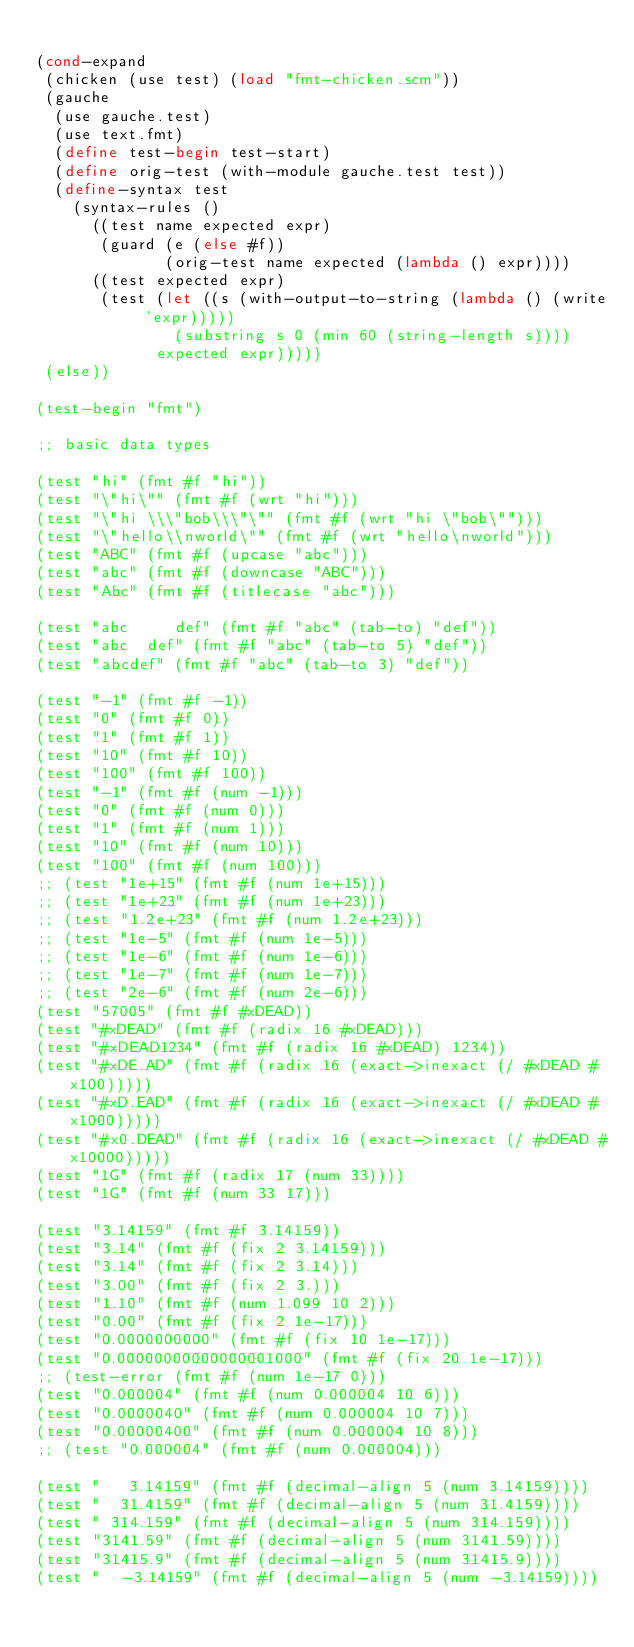<code> <loc_0><loc_0><loc_500><loc_500><_Scheme_>
(cond-expand
 (chicken (use test) (load "fmt-chicken.scm"))
 (gauche
  (use gauche.test)
  (use text.fmt)
  (define test-begin test-start)
  (define orig-test (with-module gauche.test test))
  (define-syntax test
    (syntax-rules ()
      ((test name expected expr)
       (guard (e (else #f))
              (orig-test name expected (lambda () expr))))
      ((test expected expr)
       (test (let ((s (with-output-to-string (lambda () (write 'expr)))))
               (substring s 0 (min 60 (string-length s))))
             expected expr)))))
 (else))

(test-begin "fmt")

;; basic data types

(test "hi" (fmt #f "hi"))
(test "\"hi\"" (fmt #f (wrt "hi")))
(test "\"hi \\\"bob\\\"\"" (fmt #f (wrt "hi \"bob\"")))
(test "\"hello\\nworld\"" (fmt #f (wrt "hello\nworld")))
(test "ABC" (fmt #f (upcase "abc")))
(test "abc" (fmt #f (downcase "ABC")))
(test "Abc" (fmt #f (titlecase "abc")))

(test "abc     def" (fmt #f "abc" (tab-to) "def"))
(test "abc  def" (fmt #f "abc" (tab-to 5) "def"))
(test "abcdef" (fmt #f "abc" (tab-to 3) "def"))

(test "-1" (fmt #f -1))
(test "0" (fmt #f 0))
(test "1" (fmt #f 1))
(test "10" (fmt #f 10))
(test "100" (fmt #f 100))
(test "-1" (fmt #f (num -1)))
(test "0" (fmt #f (num 0)))
(test "1" (fmt #f (num 1)))
(test "10" (fmt #f (num 10)))
(test "100" (fmt #f (num 100)))
;; (test "1e+15" (fmt #f (num 1e+15)))
;; (test "1e+23" (fmt #f (num 1e+23)))
;; (test "1.2e+23" (fmt #f (num 1.2e+23)))
;; (test "1e-5" (fmt #f (num 1e-5)))
;; (test "1e-6" (fmt #f (num 1e-6)))
;; (test "1e-7" (fmt #f (num 1e-7)))
;; (test "2e-6" (fmt #f (num 2e-6)))
(test "57005" (fmt #f #xDEAD))
(test "#xDEAD" (fmt #f (radix 16 #xDEAD)))
(test "#xDEAD1234" (fmt #f (radix 16 #xDEAD) 1234))
(test "#xDE.AD" (fmt #f (radix 16 (exact->inexact (/ #xDEAD #x100)))))
(test "#xD.EAD" (fmt #f (radix 16 (exact->inexact (/ #xDEAD #x1000)))))
(test "#x0.DEAD" (fmt #f (radix 16 (exact->inexact (/ #xDEAD #x10000)))))
(test "1G" (fmt #f (radix 17 (num 33))))
(test "1G" (fmt #f (num 33 17)))

(test "3.14159" (fmt #f 3.14159))
(test "3.14" (fmt #f (fix 2 3.14159)))
(test "3.14" (fmt #f (fix 2 3.14)))
(test "3.00" (fmt #f (fix 2 3.)))
(test "1.10" (fmt #f (num 1.099 10 2)))
(test "0.00" (fmt #f (fix 2 1e-17)))
(test "0.0000000000" (fmt #f (fix 10 1e-17)))
(test "0.00000000000000001000" (fmt #f (fix 20 1e-17)))
;; (test-error (fmt #f (num 1e-17 0)))
(test "0.000004" (fmt #f (num 0.000004 10 6)))
(test "0.0000040" (fmt #f (num 0.000004 10 7)))
(test "0.00000400" (fmt #f (num 0.000004 10 8)))
;; (test "0.000004" (fmt #f (num 0.000004)))

(test "   3.14159" (fmt #f (decimal-align 5 (num 3.14159))))
(test "  31.4159" (fmt #f (decimal-align 5 (num 31.4159))))
(test " 314.159" (fmt #f (decimal-align 5 (num 314.159))))
(test "3141.59" (fmt #f (decimal-align 5 (num 3141.59))))
(test "31415.9" (fmt #f (decimal-align 5 (num 31415.9))))
(test "  -3.14159" (fmt #f (decimal-align 5 (num -3.14159))))</code> 